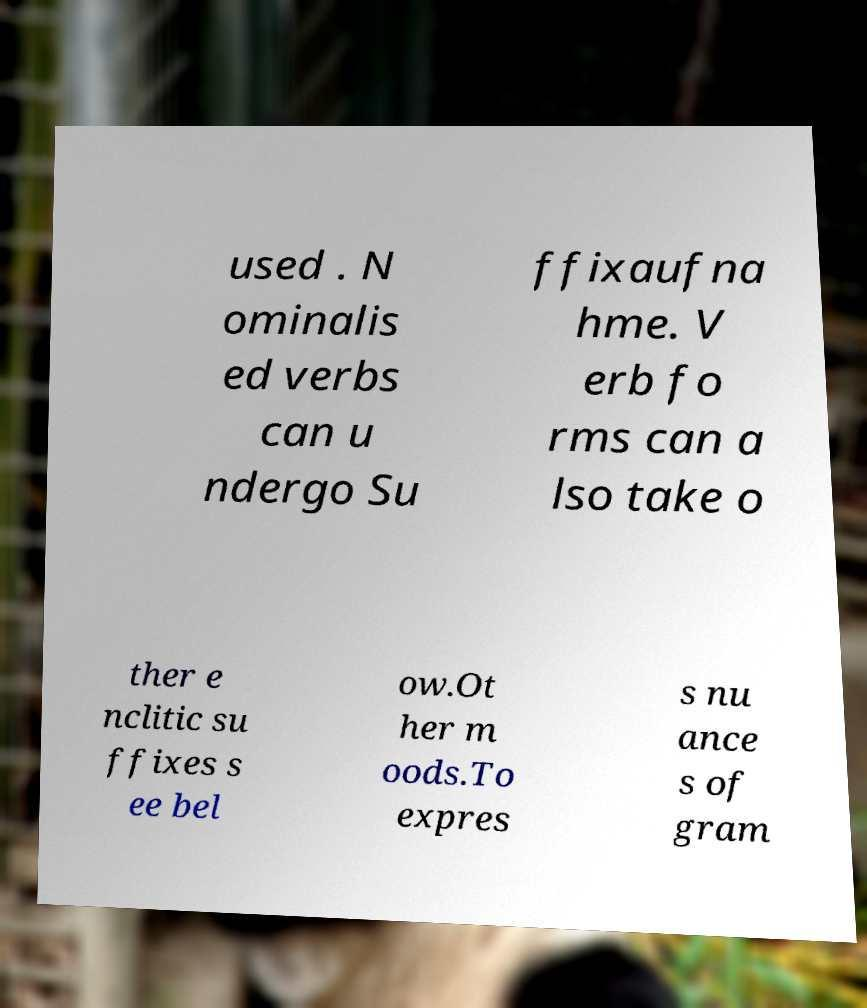There's text embedded in this image that I need extracted. Can you transcribe it verbatim? used . N ominalis ed verbs can u ndergo Su ffixaufna hme. V erb fo rms can a lso take o ther e nclitic su ffixes s ee bel ow.Ot her m oods.To expres s nu ance s of gram 